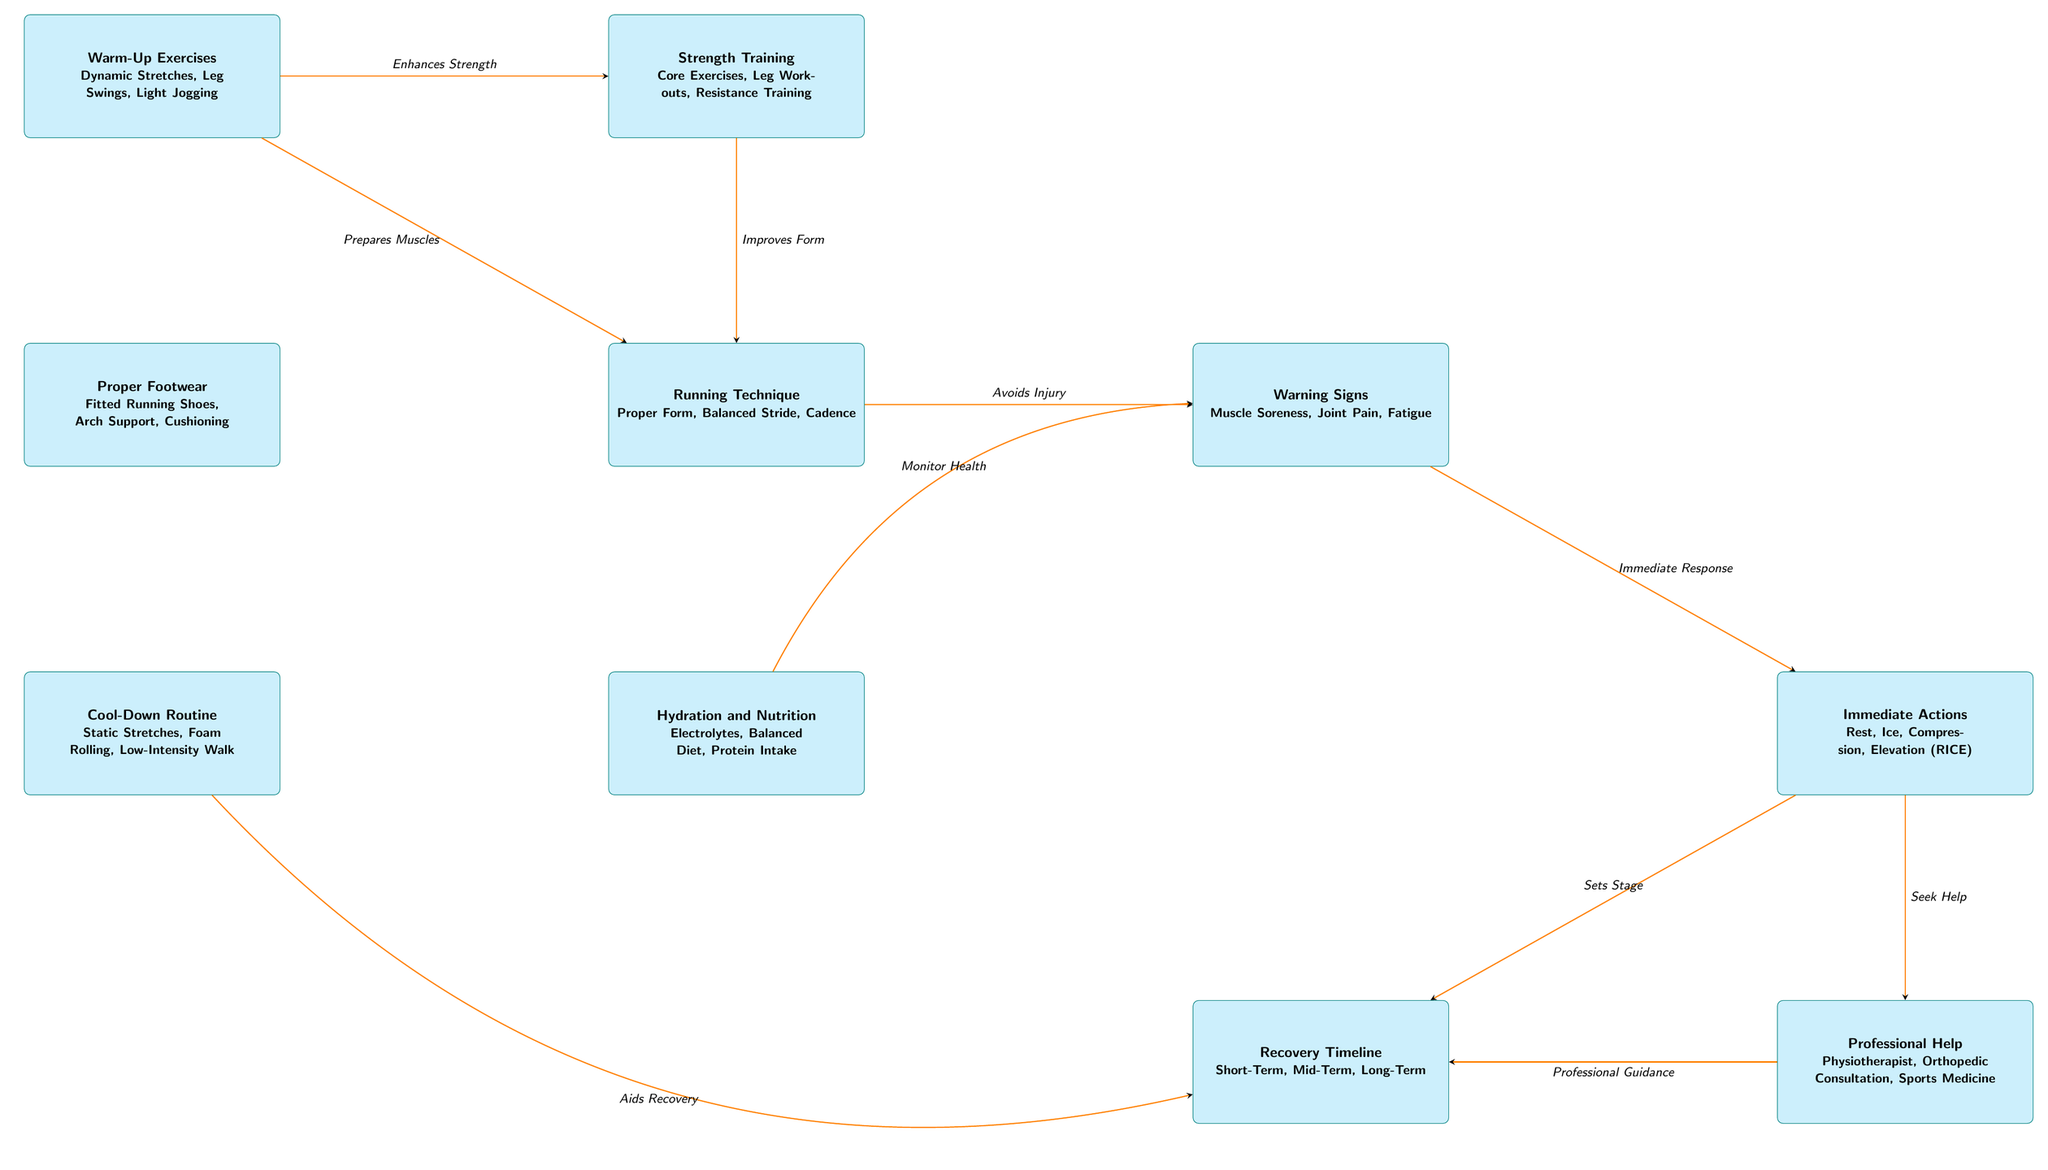What are the two main categories of techniques listed in the diagram? The diagram has two main categories: injury prevention techniques and recovery timeline. These categories are clearly labeled at the top and involve various strategies for avoiding injuries and managing recovery.
Answer: Injury prevention techniques and recovery timeline How many nodes are there in total in the diagram? The diagram contains a total of 10 nodes, each representing a different technique or stage related to injury prevention and recovery. They are grouped into distinct areas and connected by arrows indicating relationships.
Answer: 10 Which nodes are connected through the relationship "Aids Recovery"? The node "Cool-Down Routine" at the bottom left is connected through the relationship "Aids Recovery" to the node "Recovery Timeline", signifying the important role of proper cool-down in facilitating recovery.
Answer: Cool-Down Routine and Recovery Timeline What immediate actions should be taken upon noticing warning signs? The node labeled "Immediate Actions" specifies the steps to take such as Rest, Ice, Compression, and Elevation (commonly referred to as RICE) when warning signs like muscle soreness or joint pain occur.
Answer: Rest, Ice, Compression, Elevation How does Strength Training relate to Running Technique? The relationship indicates that strength training improves running form. The arrow from the "Strength Training" node to the "Running Technique" node signifies how strength development contributes positively to running technique and efficiency.
Answer: Improves Form 